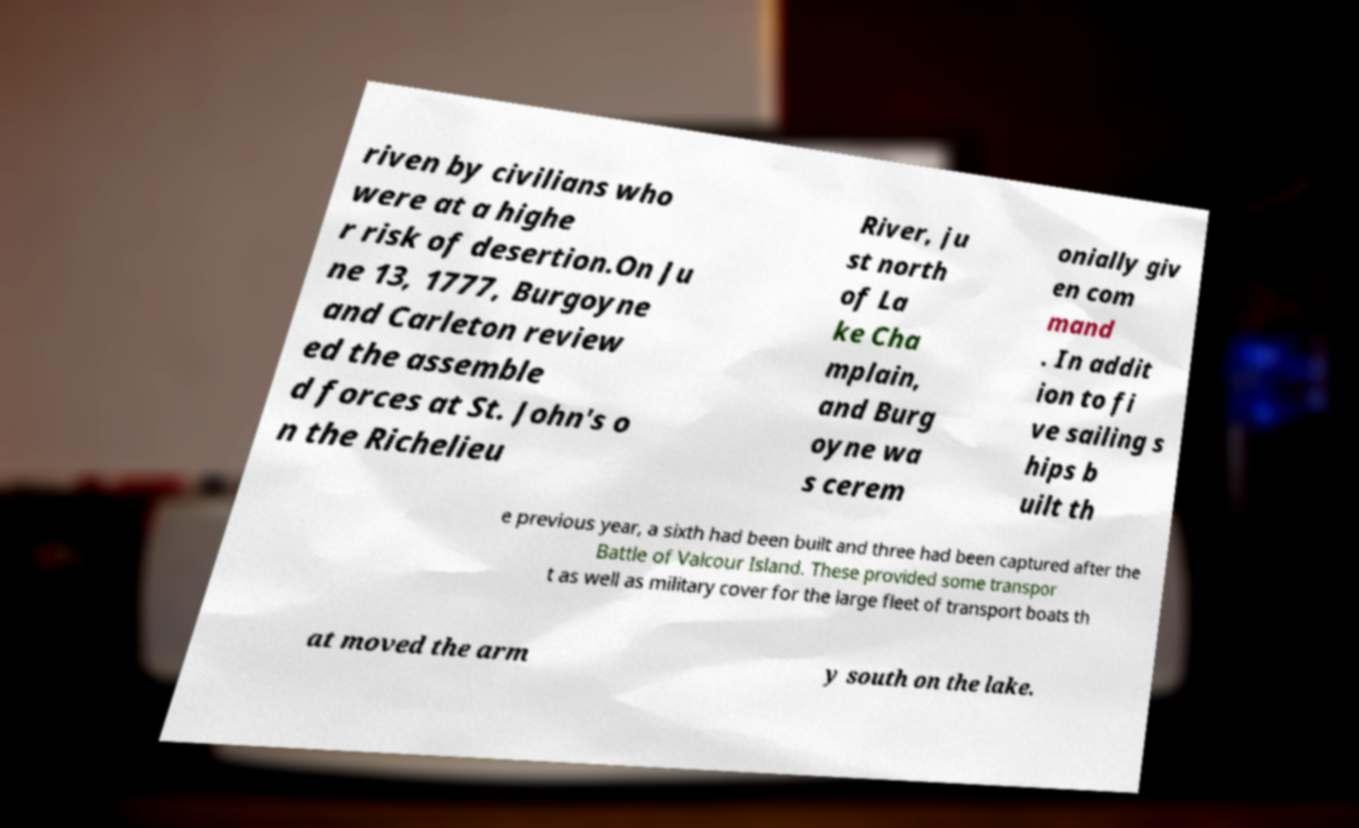Could you assist in decoding the text presented in this image and type it out clearly? riven by civilians who were at a highe r risk of desertion.On Ju ne 13, 1777, Burgoyne and Carleton review ed the assemble d forces at St. John's o n the Richelieu River, ju st north of La ke Cha mplain, and Burg oyne wa s cerem onially giv en com mand . In addit ion to fi ve sailing s hips b uilt th e previous year, a sixth had been built and three had been captured after the Battle of Valcour Island. These provided some transpor t as well as military cover for the large fleet of transport boats th at moved the arm y south on the lake. 